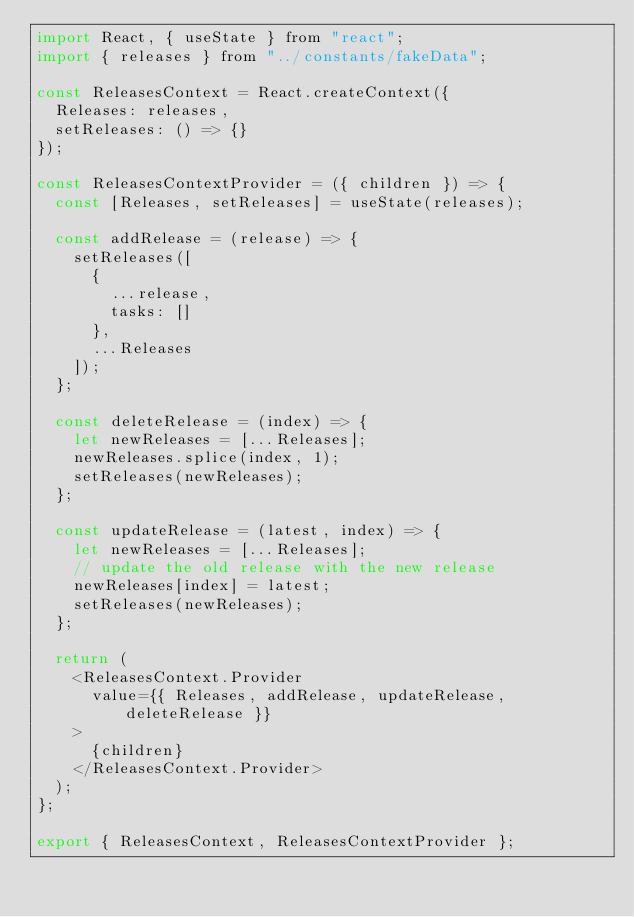Convert code to text. <code><loc_0><loc_0><loc_500><loc_500><_JavaScript_>import React, { useState } from "react";
import { releases } from "../constants/fakeData";

const ReleasesContext = React.createContext({
  Releases: releases,
  setReleases: () => {}
});

const ReleasesContextProvider = ({ children }) => {
  const [Releases, setReleases] = useState(releases);

  const addRelease = (release) => {
    setReleases([
      {
        ...release,
        tasks: []
      },
      ...Releases
    ]);
  };

  const deleteRelease = (index) => {
    let newReleases = [...Releases];
    newReleases.splice(index, 1);
    setReleases(newReleases);
  };

  const updateRelease = (latest, index) => {
    let newReleases = [...Releases];
    // update the old release with the new release
    newReleases[index] = latest;
    setReleases(newReleases);
  };

  return (
    <ReleasesContext.Provider
      value={{ Releases, addRelease, updateRelease, deleteRelease }}
    >
      {children}
    </ReleasesContext.Provider>
  );
};

export { ReleasesContext, ReleasesContextProvider };
</code> 